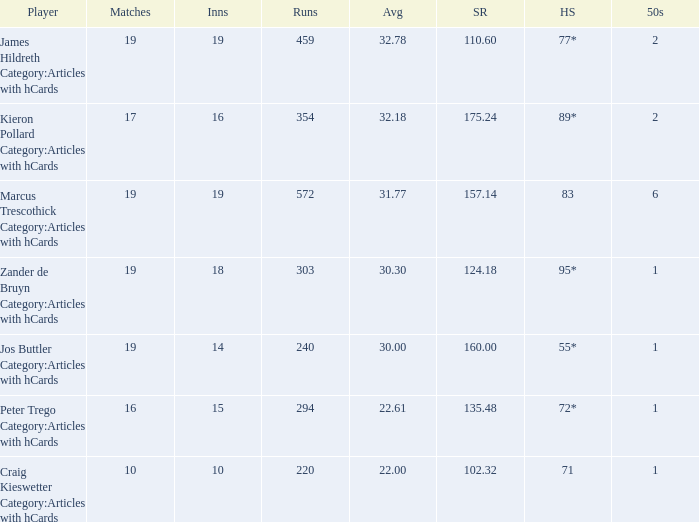How many innings for the player with an average of 22.61? 15.0. 